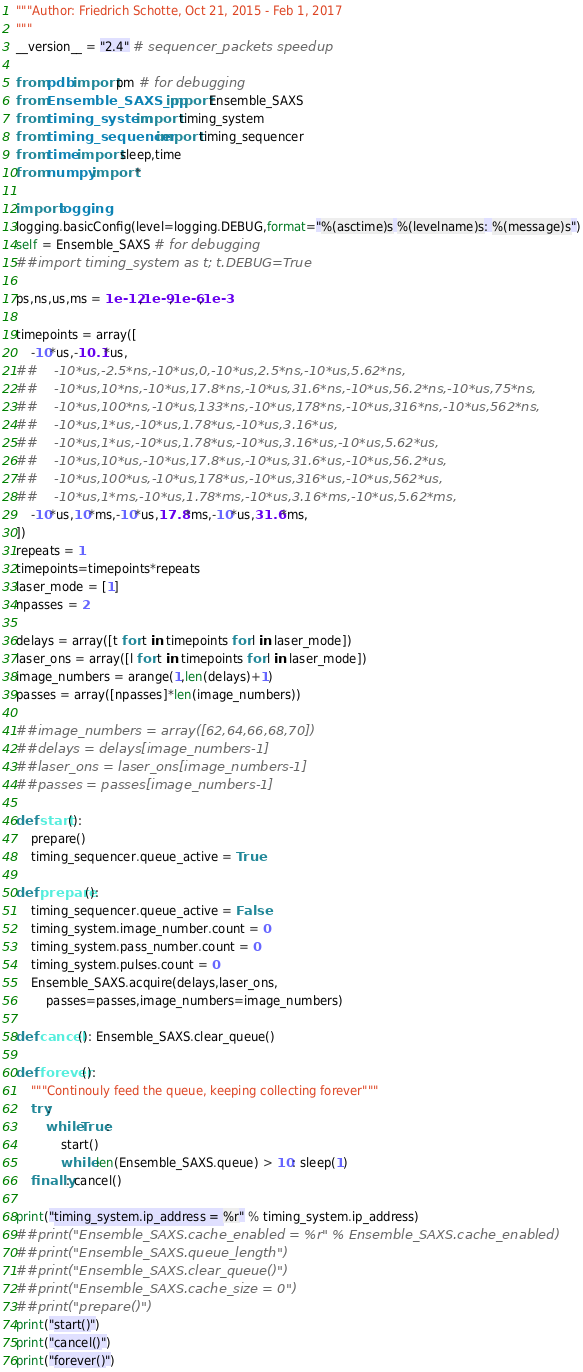<code> <loc_0><loc_0><loc_500><loc_500><_Python_>"""Author: Friedrich Schotte, Oct 21, 2015 - Feb 1, 2017
"""
__version__ = "2.4" # sequencer_packets speedup

from pdb import pm # for debugging
from Ensemble_SAXS_pp import Ensemble_SAXS
from timing_system import timing_system
from timing_sequencer import timing_sequencer
from time import sleep,time
from numpy import *

import logging
logging.basicConfig(level=logging.DEBUG,format="%(asctime)s %(levelname)s: %(message)s")
self = Ensemble_SAXS # for debugging
##import timing_system as t; t.DEBUG=True

ps,ns,us,ms = 1e-12,1e-9,1e-6,1e-3

timepoints = array([
    -10*us,-10.1*us,
##    -10*us,-2.5*ns,-10*us,0,-10*us,2.5*ns,-10*us,5.62*ns,
##    -10*us,10*ns,-10*us,17.8*ns,-10*us,31.6*ns,-10*us,56.2*ns,-10*us,75*ns,
##    -10*us,100*ns,-10*us,133*ns,-10*us,178*ns,-10*us,316*ns,-10*us,562*ns,
##    -10*us,1*us,-10*us,1.78*us,-10*us,3.16*us,
##    -10*us,1*us,-10*us,1.78*us,-10*us,3.16*us,-10*us,5.62*us,
##    -10*us,10*us,-10*us,17.8*us,-10*us,31.6*us,-10*us,56.2*us,
##    -10*us,100*us,-10*us,178*us,-10*us,316*us,-10*us,562*us,
##    -10*us,1*ms,-10*us,1.78*ms,-10*us,3.16*ms,-10*us,5.62*ms,
    -10*us,10*ms,-10*us,17.8*ms,-10*us,31.6*ms,
])
repeats = 1
timepoints=timepoints*repeats
laser_mode = [1]
npasses = 2

delays = array([t for t in timepoints for l in laser_mode])
laser_ons = array([l for t in timepoints for l in laser_mode])
image_numbers = arange(1,len(delays)+1)
passes = array([npasses]*len(image_numbers))

##image_numbers = array([62,64,66,68,70])
##delays = delays[image_numbers-1]
##laser_ons = laser_ons[image_numbers-1]
##passes = passes[image_numbers-1]

def start():
    prepare()
    timing_sequencer.queue_active = True

def prepare():
    timing_sequencer.queue_active = False
    timing_system.image_number.count = 0
    timing_system.pass_number.count = 0
    timing_system.pulses.count = 0
    Ensemble_SAXS.acquire(delays,laser_ons,
        passes=passes,image_numbers=image_numbers)

def cancel(): Ensemble_SAXS.clear_queue()
    
def forever():
    """Continouly feed the queue, keeping collecting forever"""
    try:
        while True:
            start()
            while len(Ensemble_SAXS.queue) > 10: sleep(1)
    finally: cancel()

print("timing_system.ip_address = %r" % timing_system.ip_address)
##print("Ensemble_SAXS.cache_enabled = %r" % Ensemble_SAXS.cache_enabled)
##print("Ensemble_SAXS.queue_length")
##print("Ensemble_SAXS.clear_queue()")
##print("Ensemble_SAXS.cache_size = 0")
##print("prepare()")
print("start()")
print("cancel()")
print("forever()")
</code> 